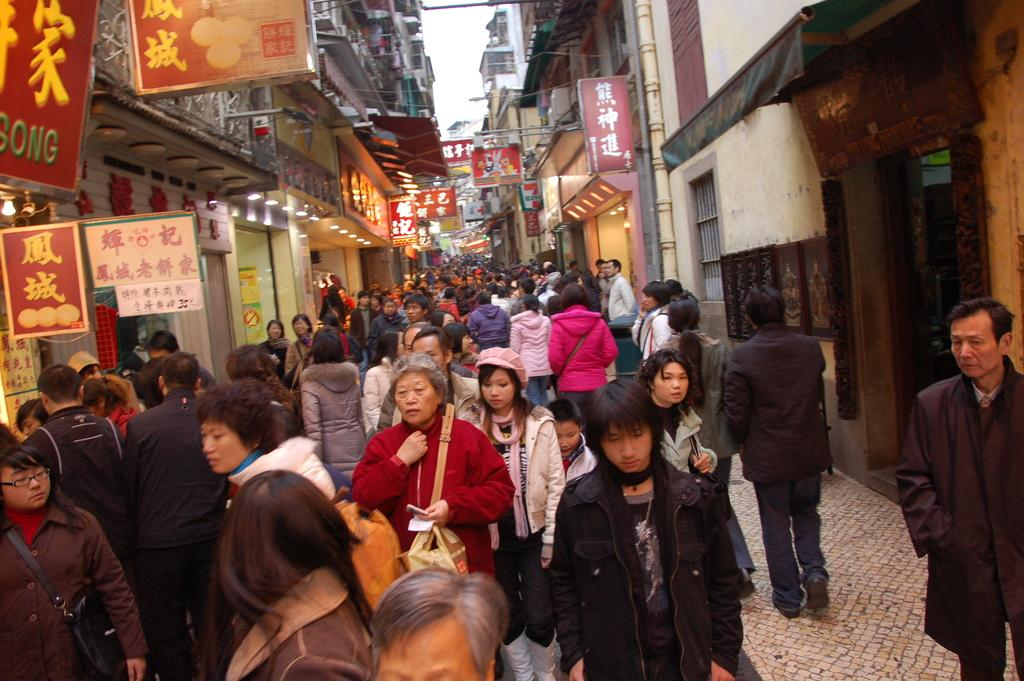What are the people in the image doing? The people in the image are walking on the path in the foreground. What can be seen on either side of the path? There are boards and buildings on either side of the path. What else is present on either side of the path? There are lights on either side of the path. What can be seen in the background of the image? The sky is visible in the background of the image. What type of beef is being served at the restaurant in the image? There is no restaurant or beef present in the image; it features people walking on a path with boards, buildings, and lights on either side. How many clovers can be seen growing on the path in the image? There are no clovers visible on the path in the image. 